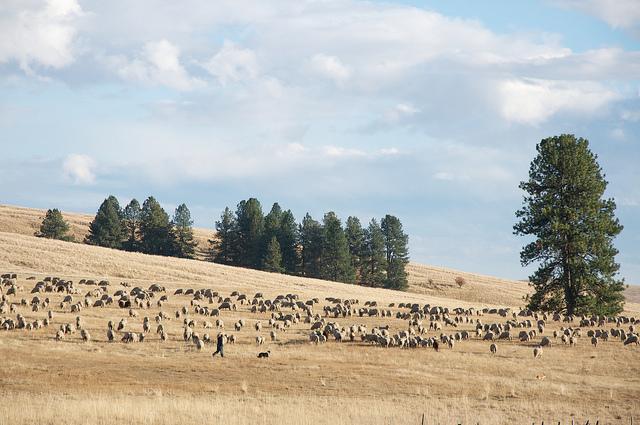How many elephants are there?
Give a very brief answer. 0. 